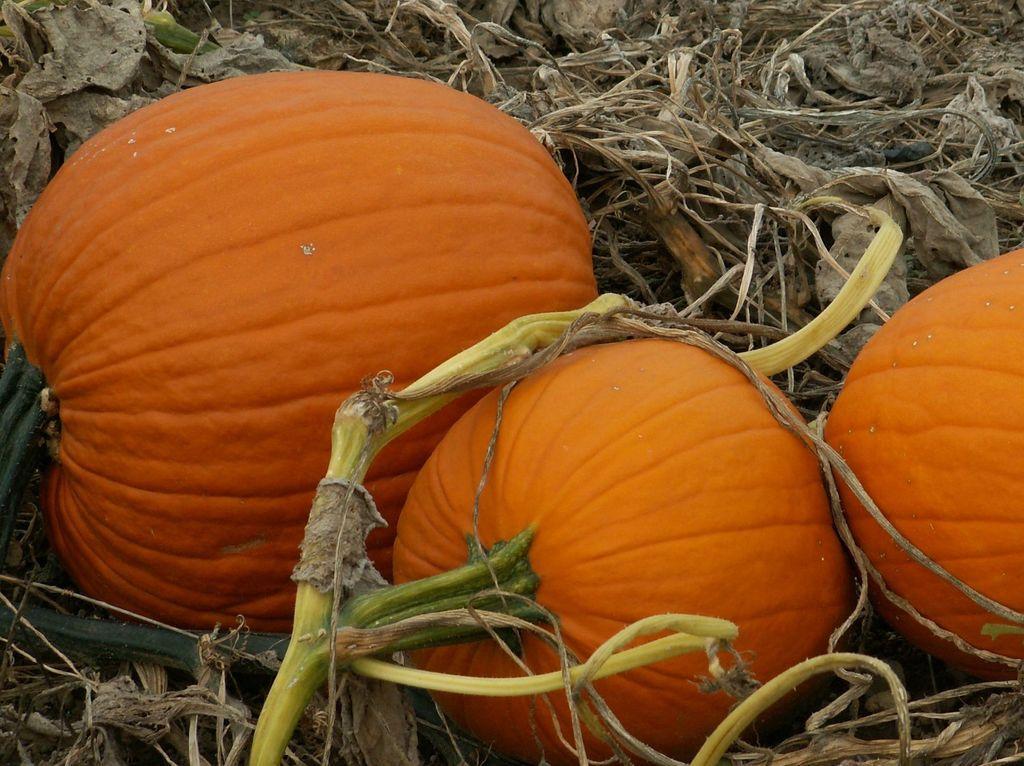Describe this image in one or two sentences. In the center of the image there are pumpkins. At the bottom of the image there is dried leaves 